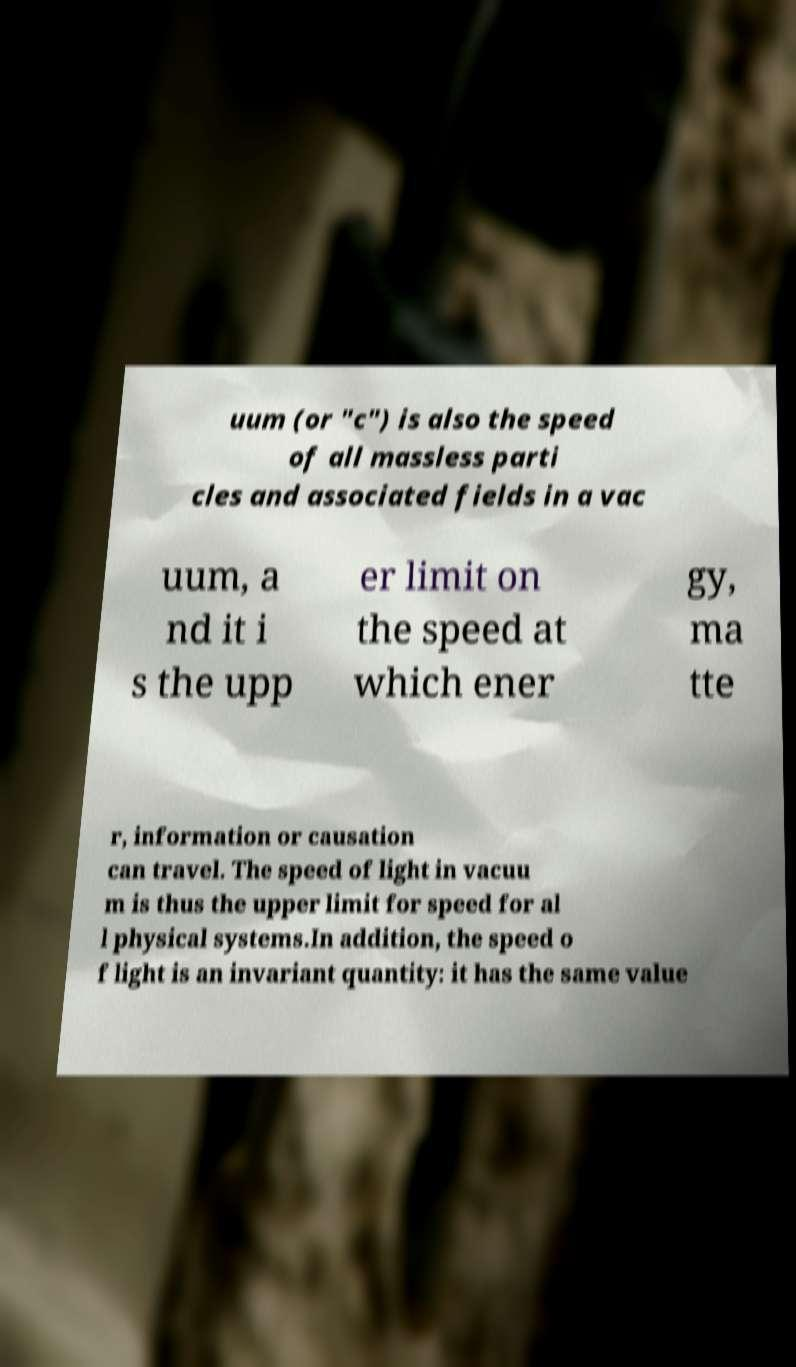Could you assist in decoding the text presented in this image and type it out clearly? uum (or "c") is also the speed of all massless parti cles and associated fields in a vac uum, a nd it i s the upp er limit on the speed at which ener gy, ma tte r, information or causation can travel. The speed of light in vacuu m is thus the upper limit for speed for al l physical systems.In addition, the speed o f light is an invariant quantity: it has the same value 